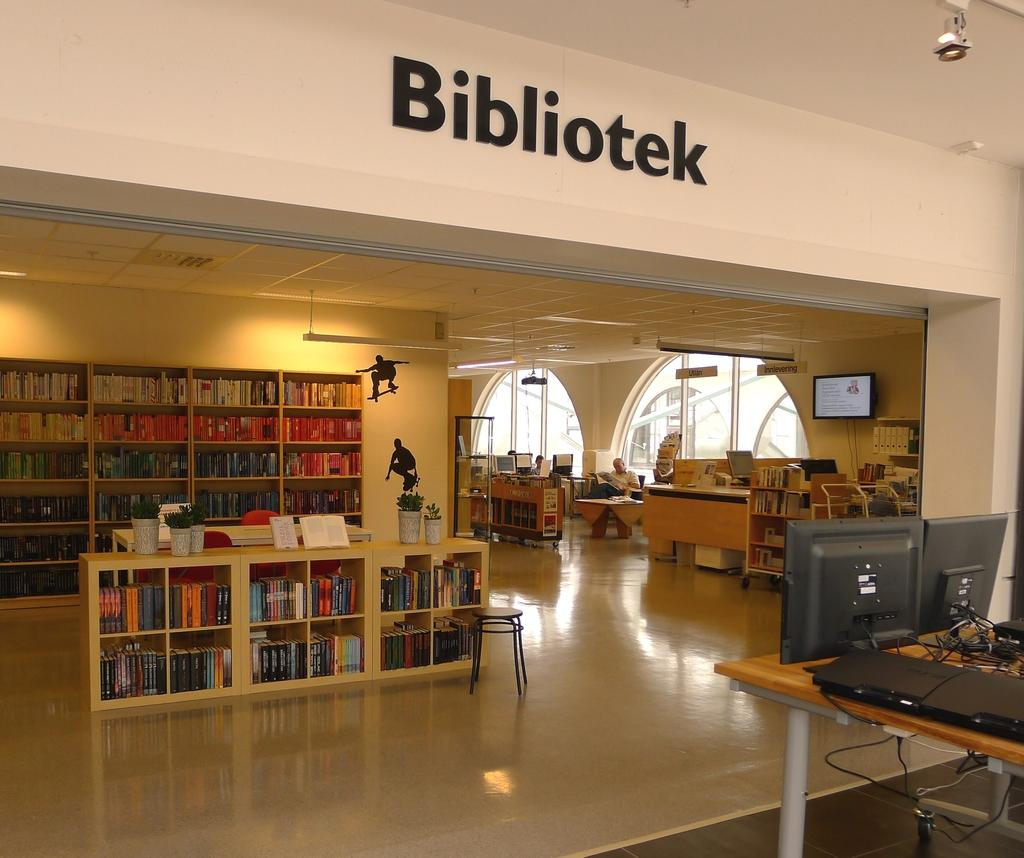What type of furniture is present in the image? There are wooden shelves in the image. What can be found on the shelves? The shelves contain books. What electronic devices are on the right side of the table? There are monitors on the right side of the table. What is written at the top of the image? The top of the image has the name "BIBLIOTECA." How many dogs are sitting on the wooden shelves in the image? There are no dogs present in the image; it features wooden shelves with books. What color is the rose on the right side of the table? There is no rose present in the image; it features monitors on the right side of the table. 